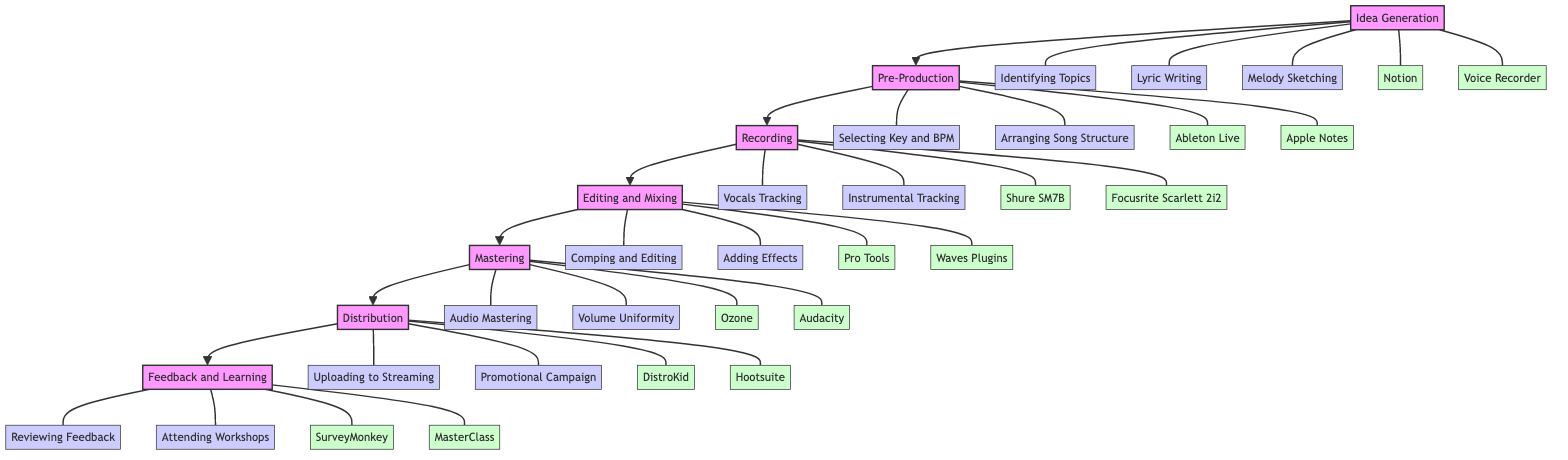What is the first stage of the music production workflow? The diagram shows the stages in a left-to-right flow. The first stage listed on the left is "Idea Generation."
Answer: Idea Generation How many tools are used in the Recording stage? In the Recording stage, there are two tools listed: "Shure SM7B Microphone" and "Focusrite Scarlett 2i2 Audio Interface." Thus, the count is two.
Answer: 2 What is the last milestone in the distribution process? The diagram indicates that the last milestone under Distribution is "Promotional Campaign."
Answer: Promotional Campaign Which tool is used for feedback collection? In the Feedback and Learning stage, "SurveyMonkey" is specifically designated for gathering feedback.
Answer: SurveyMonkey What is the relationship between Editing and Mixing and Mastering? The diagram shows a direct connection flowing from "Editing and Mixing" to "Mastering," signifying that after editing and mixing, the next step is mastering.
Answer: Editing and Mixing leads to Mastering How many milestones are there in total across all stages? The stages include various milestones: Idea Generation (3), Pre-Production (2), Recording (2), Editing and Mixing (2), Mastering (2), Distribution (2), and Feedback and Learning (2). Adding these gives a total of 15 milestones.
Answer: 15 Which tool is used for music distribution? The tool specifically designated for distribution in the diagram is "DistroKid."
Answer: DistroKid What is the purpose of the Mastering stage? The description for the Mastering stage in the diagram states that here, the purpose is "Finalizing the track for distribution."
Answer: Finalizing the track for distribution What stage follows the Recording stage? The diagram's flow indicates that the stage immediately following "Recording" is "Editing and Mixing."
Answer: Editing and Mixing 